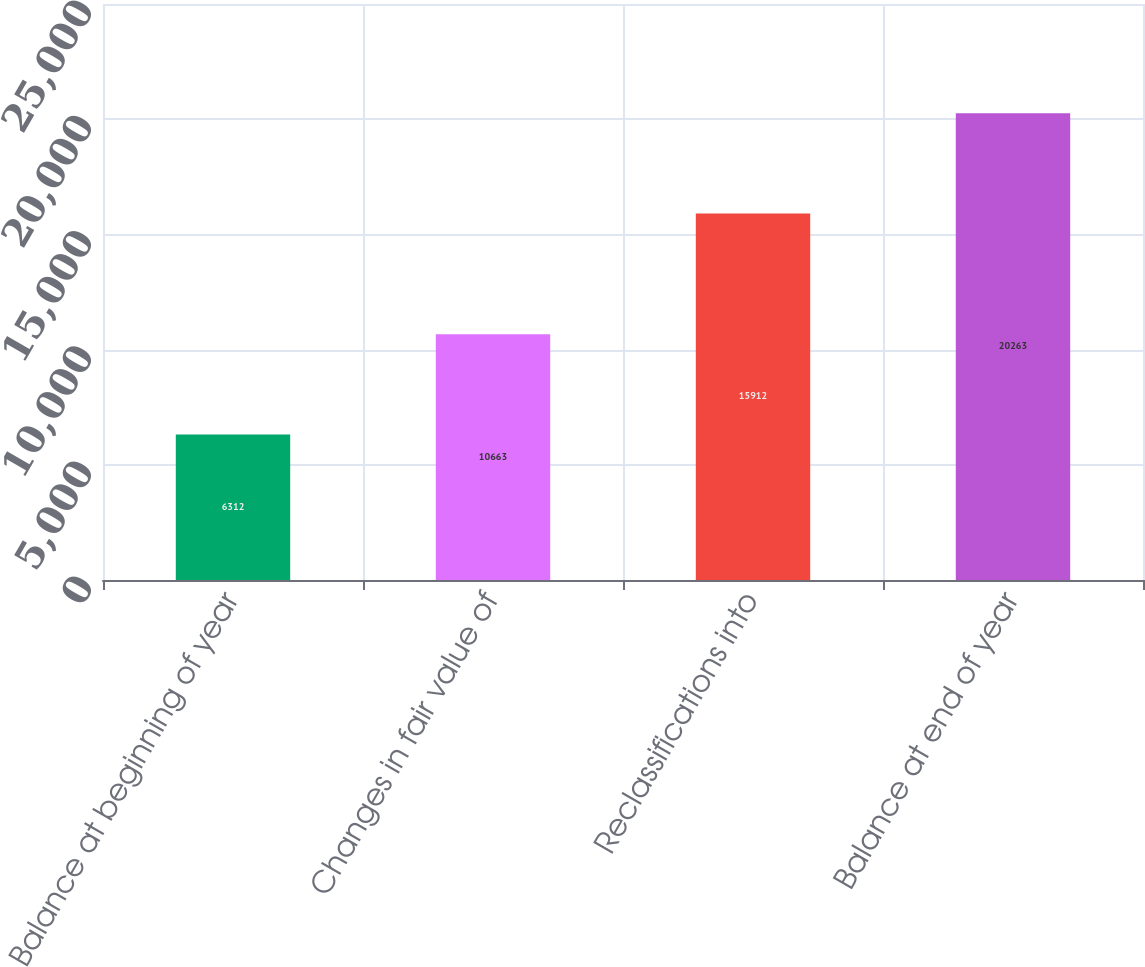Convert chart. <chart><loc_0><loc_0><loc_500><loc_500><bar_chart><fcel>Balance at beginning of year<fcel>Changes in fair value of<fcel>Reclassifications into<fcel>Balance at end of year<nl><fcel>6312<fcel>10663<fcel>15912<fcel>20263<nl></chart> 